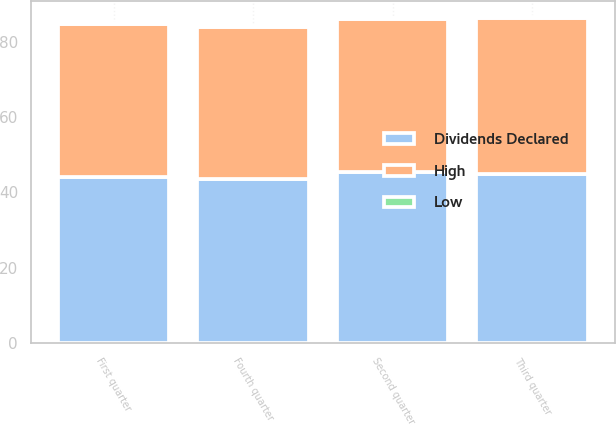<chart> <loc_0><loc_0><loc_500><loc_500><stacked_bar_chart><ecel><fcel>Fourth quarter<fcel>Third quarter<fcel>Second quarter<fcel>First quarter<nl><fcel>Dividends Declared<fcel>43.6<fcel>44.75<fcel>45.26<fcel>44.15<nl><fcel>High<fcel>40.31<fcel>41.39<fcel>40.74<fcel>40.55<nl><fcel>Low<fcel>0.28<fcel>0.28<fcel>0.28<fcel>0.28<nl></chart> 